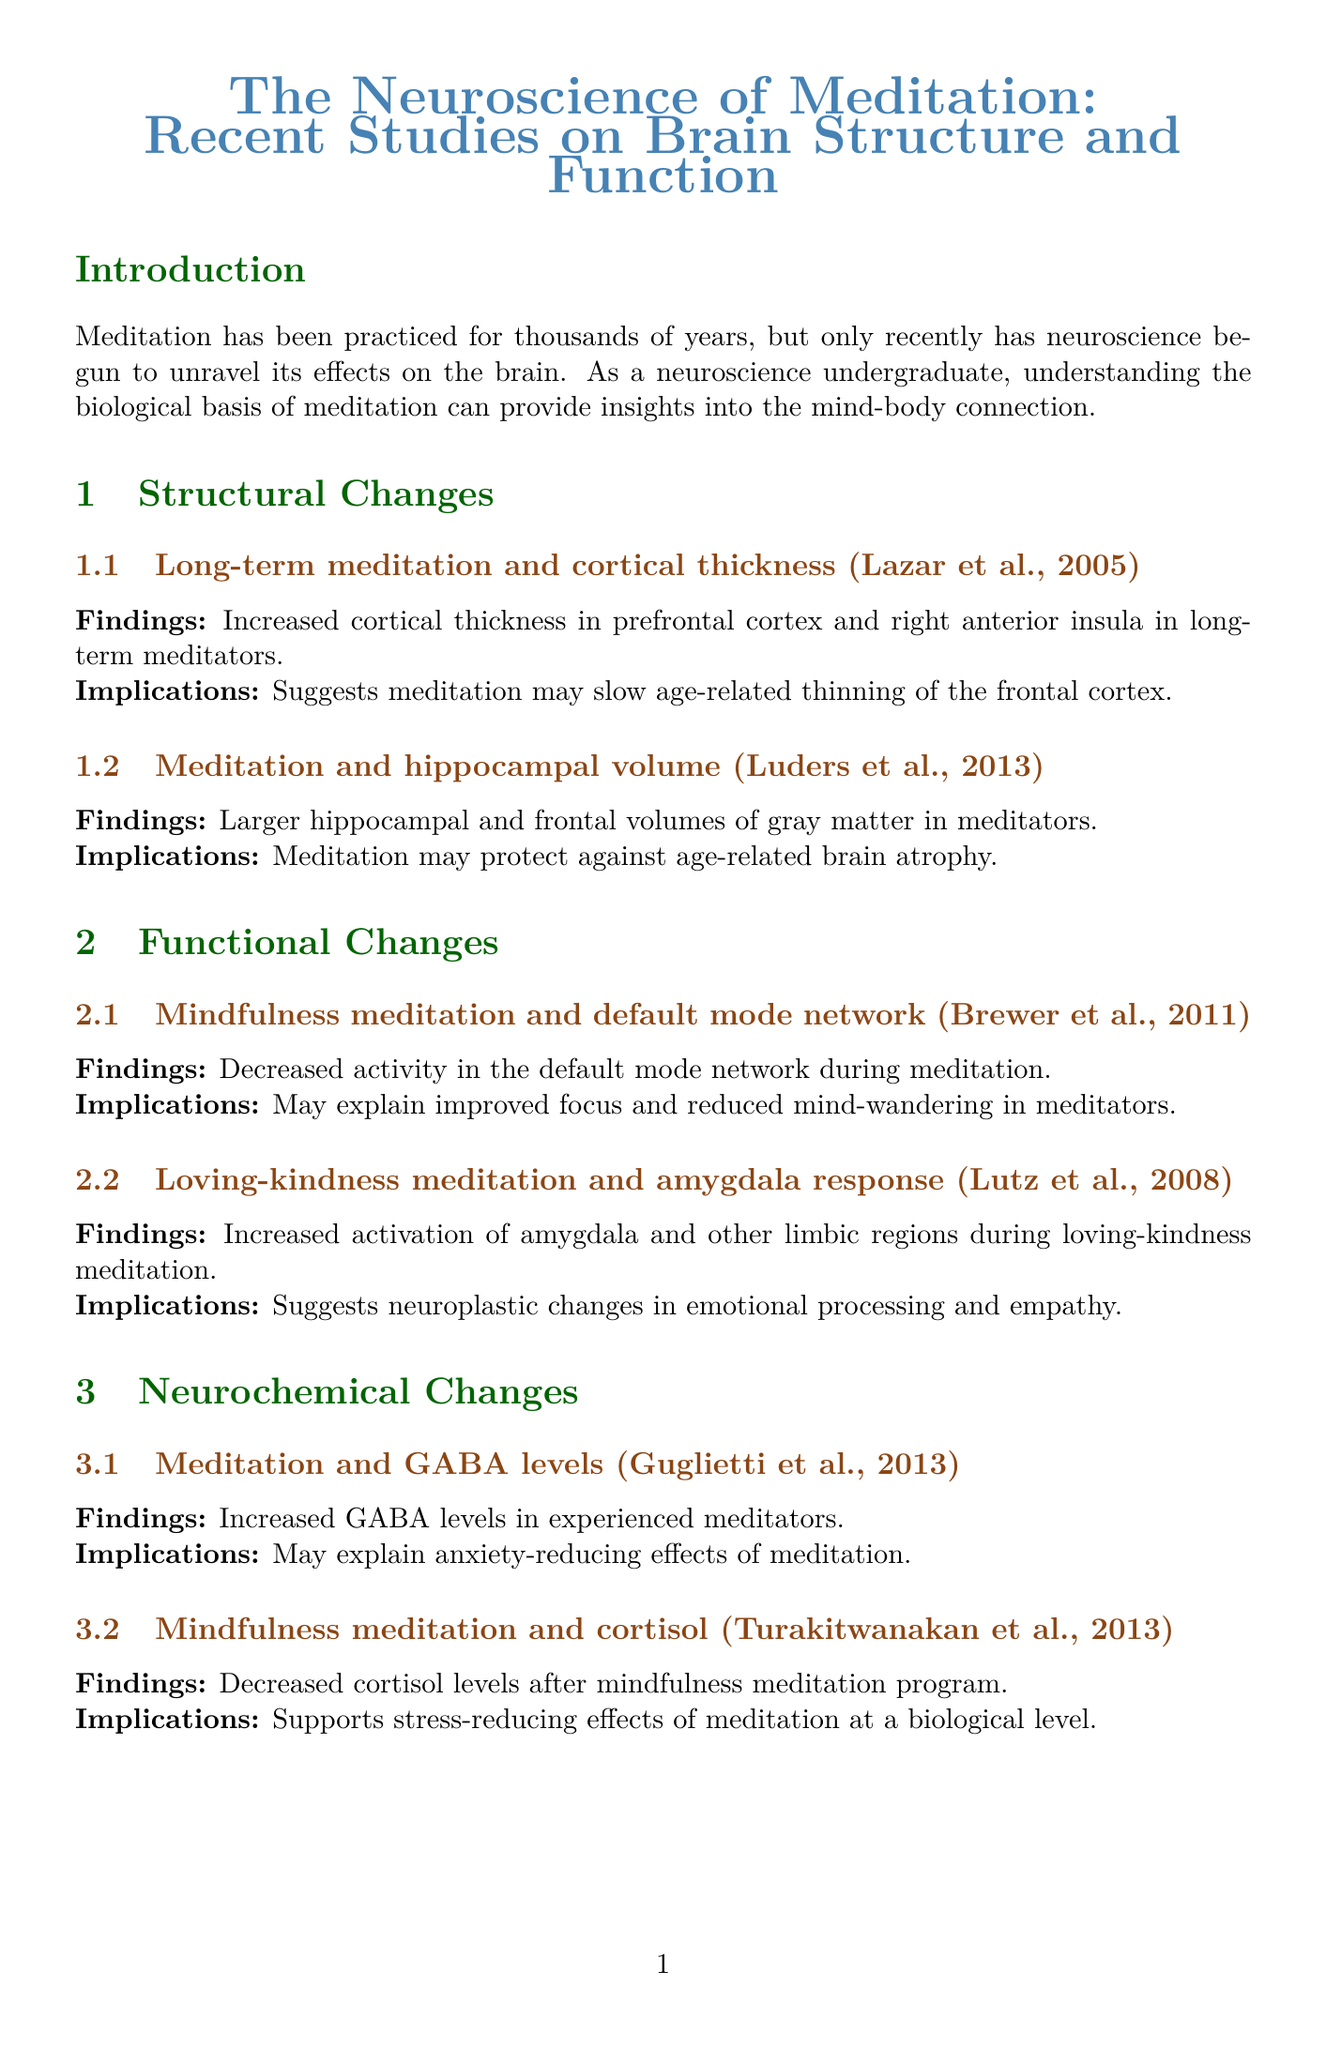What is the title of the report? The title of the report is stated at the beginning and provides the overall theme of the document.
Answer: The Neuroscience of Meditation: Recent Studies on Brain Structure and Function Who conducted the study on long-term meditation and cortical thickness? The report mentions specific researchers associated with each study, which includes their names in the findings.
Answer: Lazar et al., 2005 What change was observed in the hippocampal volume according to the study by Luders et al.? The document states specific findings related to the impact of meditation on brain structures, specifically mentioning the hippocampal volume.
Answer: Larger hippocampal and frontal volumes of gray matter in meditators Which neurochemical level increased in experienced meditators according to Guglietti et al.? This information is highlighted under the neurochemical changes section of the document, specifying the effects of meditation.
Answer: GABA levels What is one implication of increased functional connectivity in mindfulness meditation according to Kilpatrick et al.? The implications of the findings are provided, offering insight into the effects of enhanced connectivity on mental processes.
Answer: Enhanced self-regulation and cognitive control How might future studies enhance our understanding of meditation's impact on the brain? Future directions in the document outline proposed methodologies to investigate meditation's effects further.
Answer: Longitudinal studies to track brain changes over extended periods of meditation practice What aspect of meditation does Lutz et al.’s study focus on? This question concerns the context and specifics of particular studies mentioned in the document, directing to the findings related to meditation techniques.
Answer: Loving-kindness meditation and amygdala response What do the findings suggest about the relationship between meditation and anxiety? The relationship drawn between findings and their implications highlights specific outcomes linked to meditation.
Answer: May explain anxiety-reducing effects of meditation 